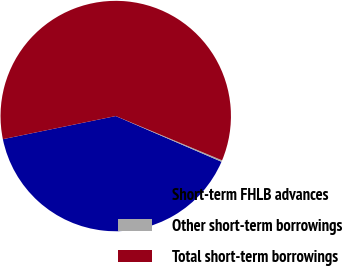Convert chart to OTSL. <chart><loc_0><loc_0><loc_500><loc_500><pie_chart><fcel>Short-term FHLB advances<fcel>Other short-term borrowings<fcel>Total short-term borrowings<nl><fcel>40.29%<fcel>0.21%<fcel>59.5%<nl></chart> 